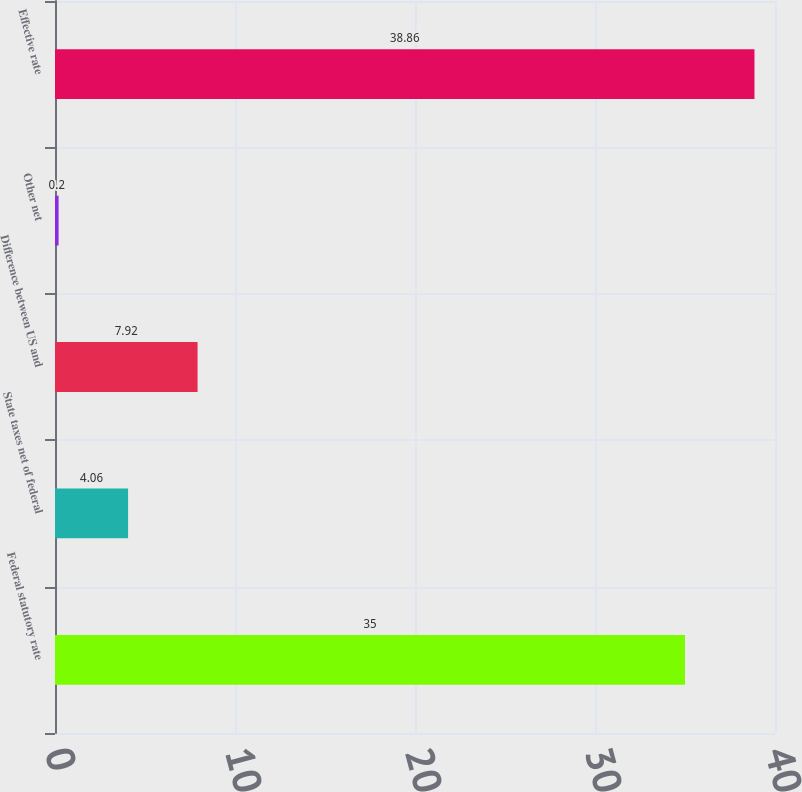<chart> <loc_0><loc_0><loc_500><loc_500><bar_chart><fcel>Federal statutory rate<fcel>State taxes net of federal<fcel>Difference between US and<fcel>Other net<fcel>Effective rate<nl><fcel>35<fcel>4.06<fcel>7.92<fcel>0.2<fcel>38.86<nl></chart> 